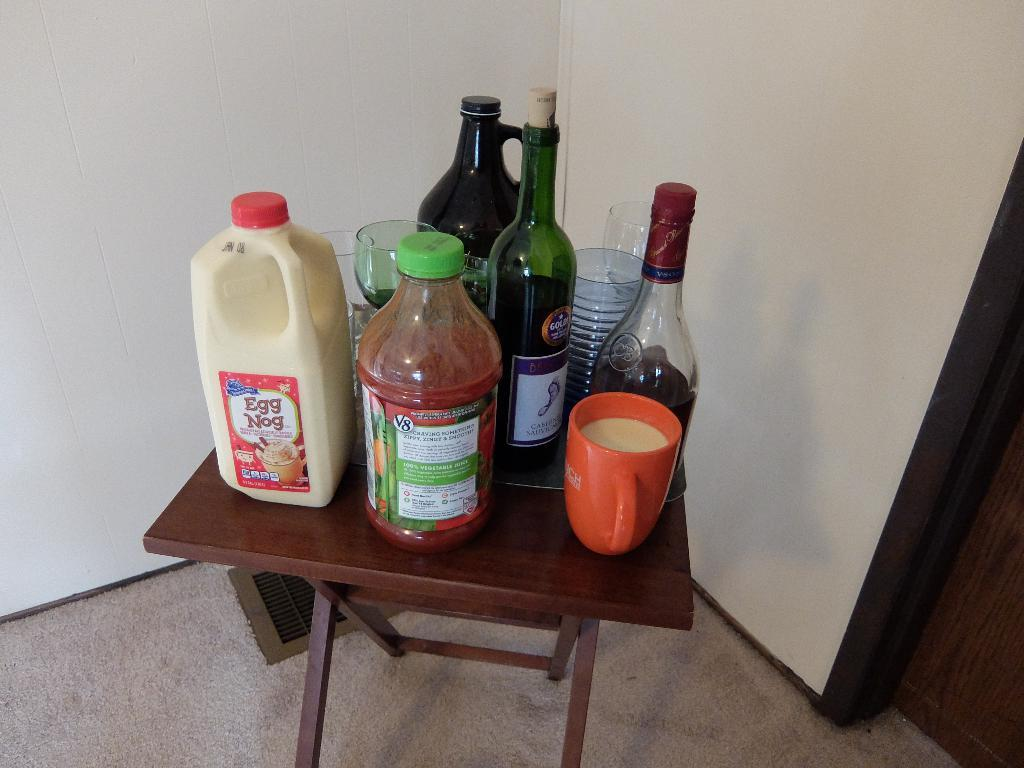Provide a one-sentence caption for the provided image. Milk, juice, and wine on a small brown table with cups and glasses. 